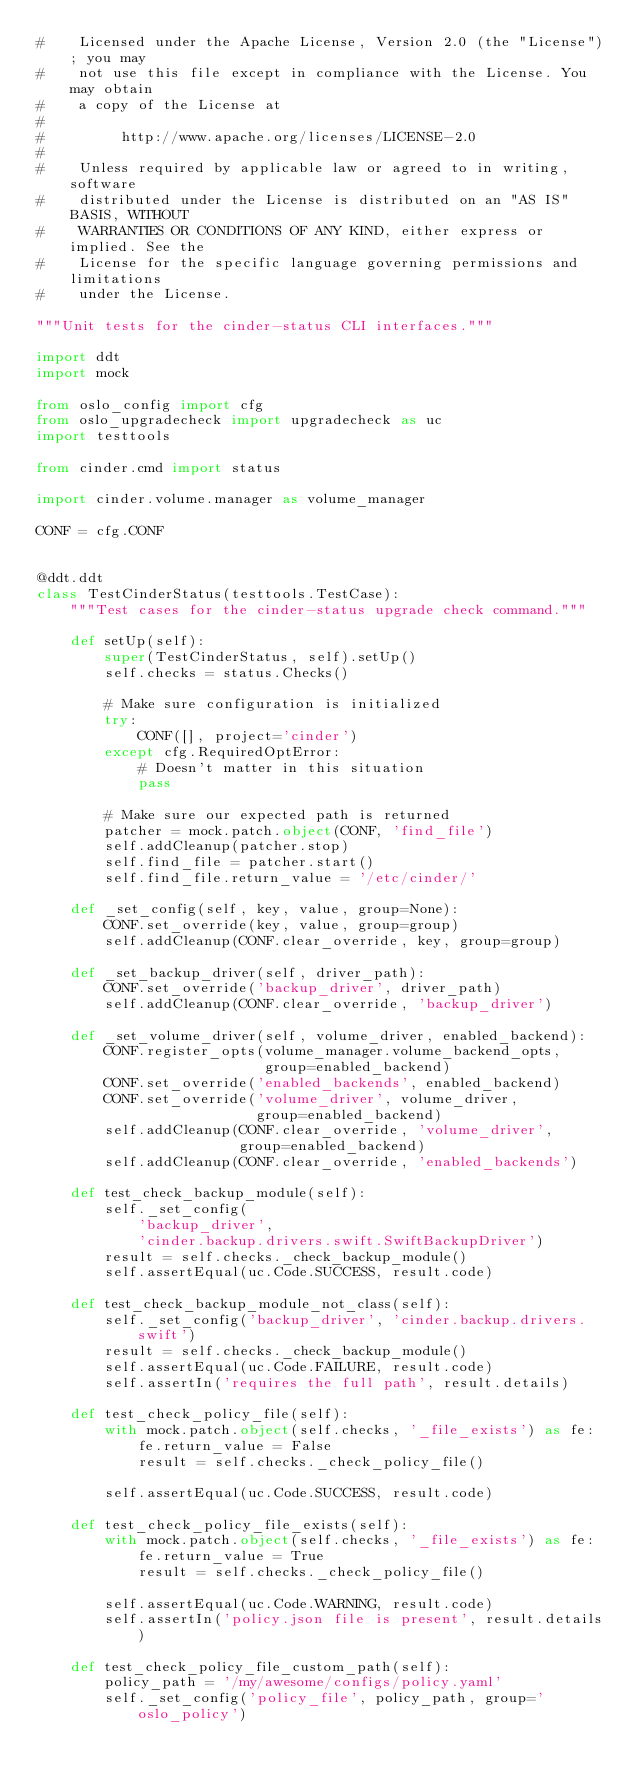Convert code to text. <code><loc_0><loc_0><loc_500><loc_500><_Python_>#    Licensed under the Apache License, Version 2.0 (the "License"); you may
#    not use this file except in compliance with the License. You may obtain
#    a copy of the License at
#
#         http://www.apache.org/licenses/LICENSE-2.0
#
#    Unless required by applicable law or agreed to in writing, software
#    distributed under the License is distributed on an "AS IS" BASIS, WITHOUT
#    WARRANTIES OR CONDITIONS OF ANY KIND, either express or implied. See the
#    License for the specific language governing permissions and limitations
#    under the License.

"""Unit tests for the cinder-status CLI interfaces."""

import ddt
import mock

from oslo_config import cfg
from oslo_upgradecheck import upgradecheck as uc
import testtools

from cinder.cmd import status

import cinder.volume.manager as volume_manager

CONF = cfg.CONF


@ddt.ddt
class TestCinderStatus(testtools.TestCase):
    """Test cases for the cinder-status upgrade check command."""

    def setUp(self):
        super(TestCinderStatus, self).setUp()
        self.checks = status.Checks()

        # Make sure configuration is initialized
        try:
            CONF([], project='cinder')
        except cfg.RequiredOptError:
            # Doesn't matter in this situation
            pass

        # Make sure our expected path is returned
        patcher = mock.patch.object(CONF, 'find_file')
        self.addCleanup(patcher.stop)
        self.find_file = patcher.start()
        self.find_file.return_value = '/etc/cinder/'

    def _set_config(self, key, value, group=None):
        CONF.set_override(key, value, group=group)
        self.addCleanup(CONF.clear_override, key, group=group)

    def _set_backup_driver(self, driver_path):
        CONF.set_override('backup_driver', driver_path)
        self.addCleanup(CONF.clear_override, 'backup_driver')

    def _set_volume_driver(self, volume_driver, enabled_backend):
        CONF.register_opts(volume_manager.volume_backend_opts,
                           group=enabled_backend)
        CONF.set_override('enabled_backends', enabled_backend)
        CONF.set_override('volume_driver', volume_driver,
                          group=enabled_backend)
        self.addCleanup(CONF.clear_override, 'volume_driver',
                        group=enabled_backend)
        self.addCleanup(CONF.clear_override, 'enabled_backends')

    def test_check_backup_module(self):
        self._set_config(
            'backup_driver',
            'cinder.backup.drivers.swift.SwiftBackupDriver')
        result = self.checks._check_backup_module()
        self.assertEqual(uc.Code.SUCCESS, result.code)

    def test_check_backup_module_not_class(self):
        self._set_config('backup_driver', 'cinder.backup.drivers.swift')
        result = self.checks._check_backup_module()
        self.assertEqual(uc.Code.FAILURE, result.code)
        self.assertIn('requires the full path', result.details)

    def test_check_policy_file(self):
        with mock.patch.object(self.checks, '_file_exists') as fe:
            fe.return_value = False
            result = self.checks._check_policy_file()

        self.assertEqual(uc.Code.SUCCESS, result.code)

    def test_check_policy_file_exists(self):
        with mock.patch.object(self.checks, '_file_exists') as fe:
            fe.return_value = True
            result = self.checks._check_policy_file()

        self.assertEqual(uc.Code.WARNING, result.code)
        self.assertIn('policy.json file is present', result.details)

    def test_check_policy_file_custom_path(self):
        policy_path = '/my/awesome/configs/policy.yaml'
        self._set_config('policy_file', policy_path, group='oslo_policy')</code> 